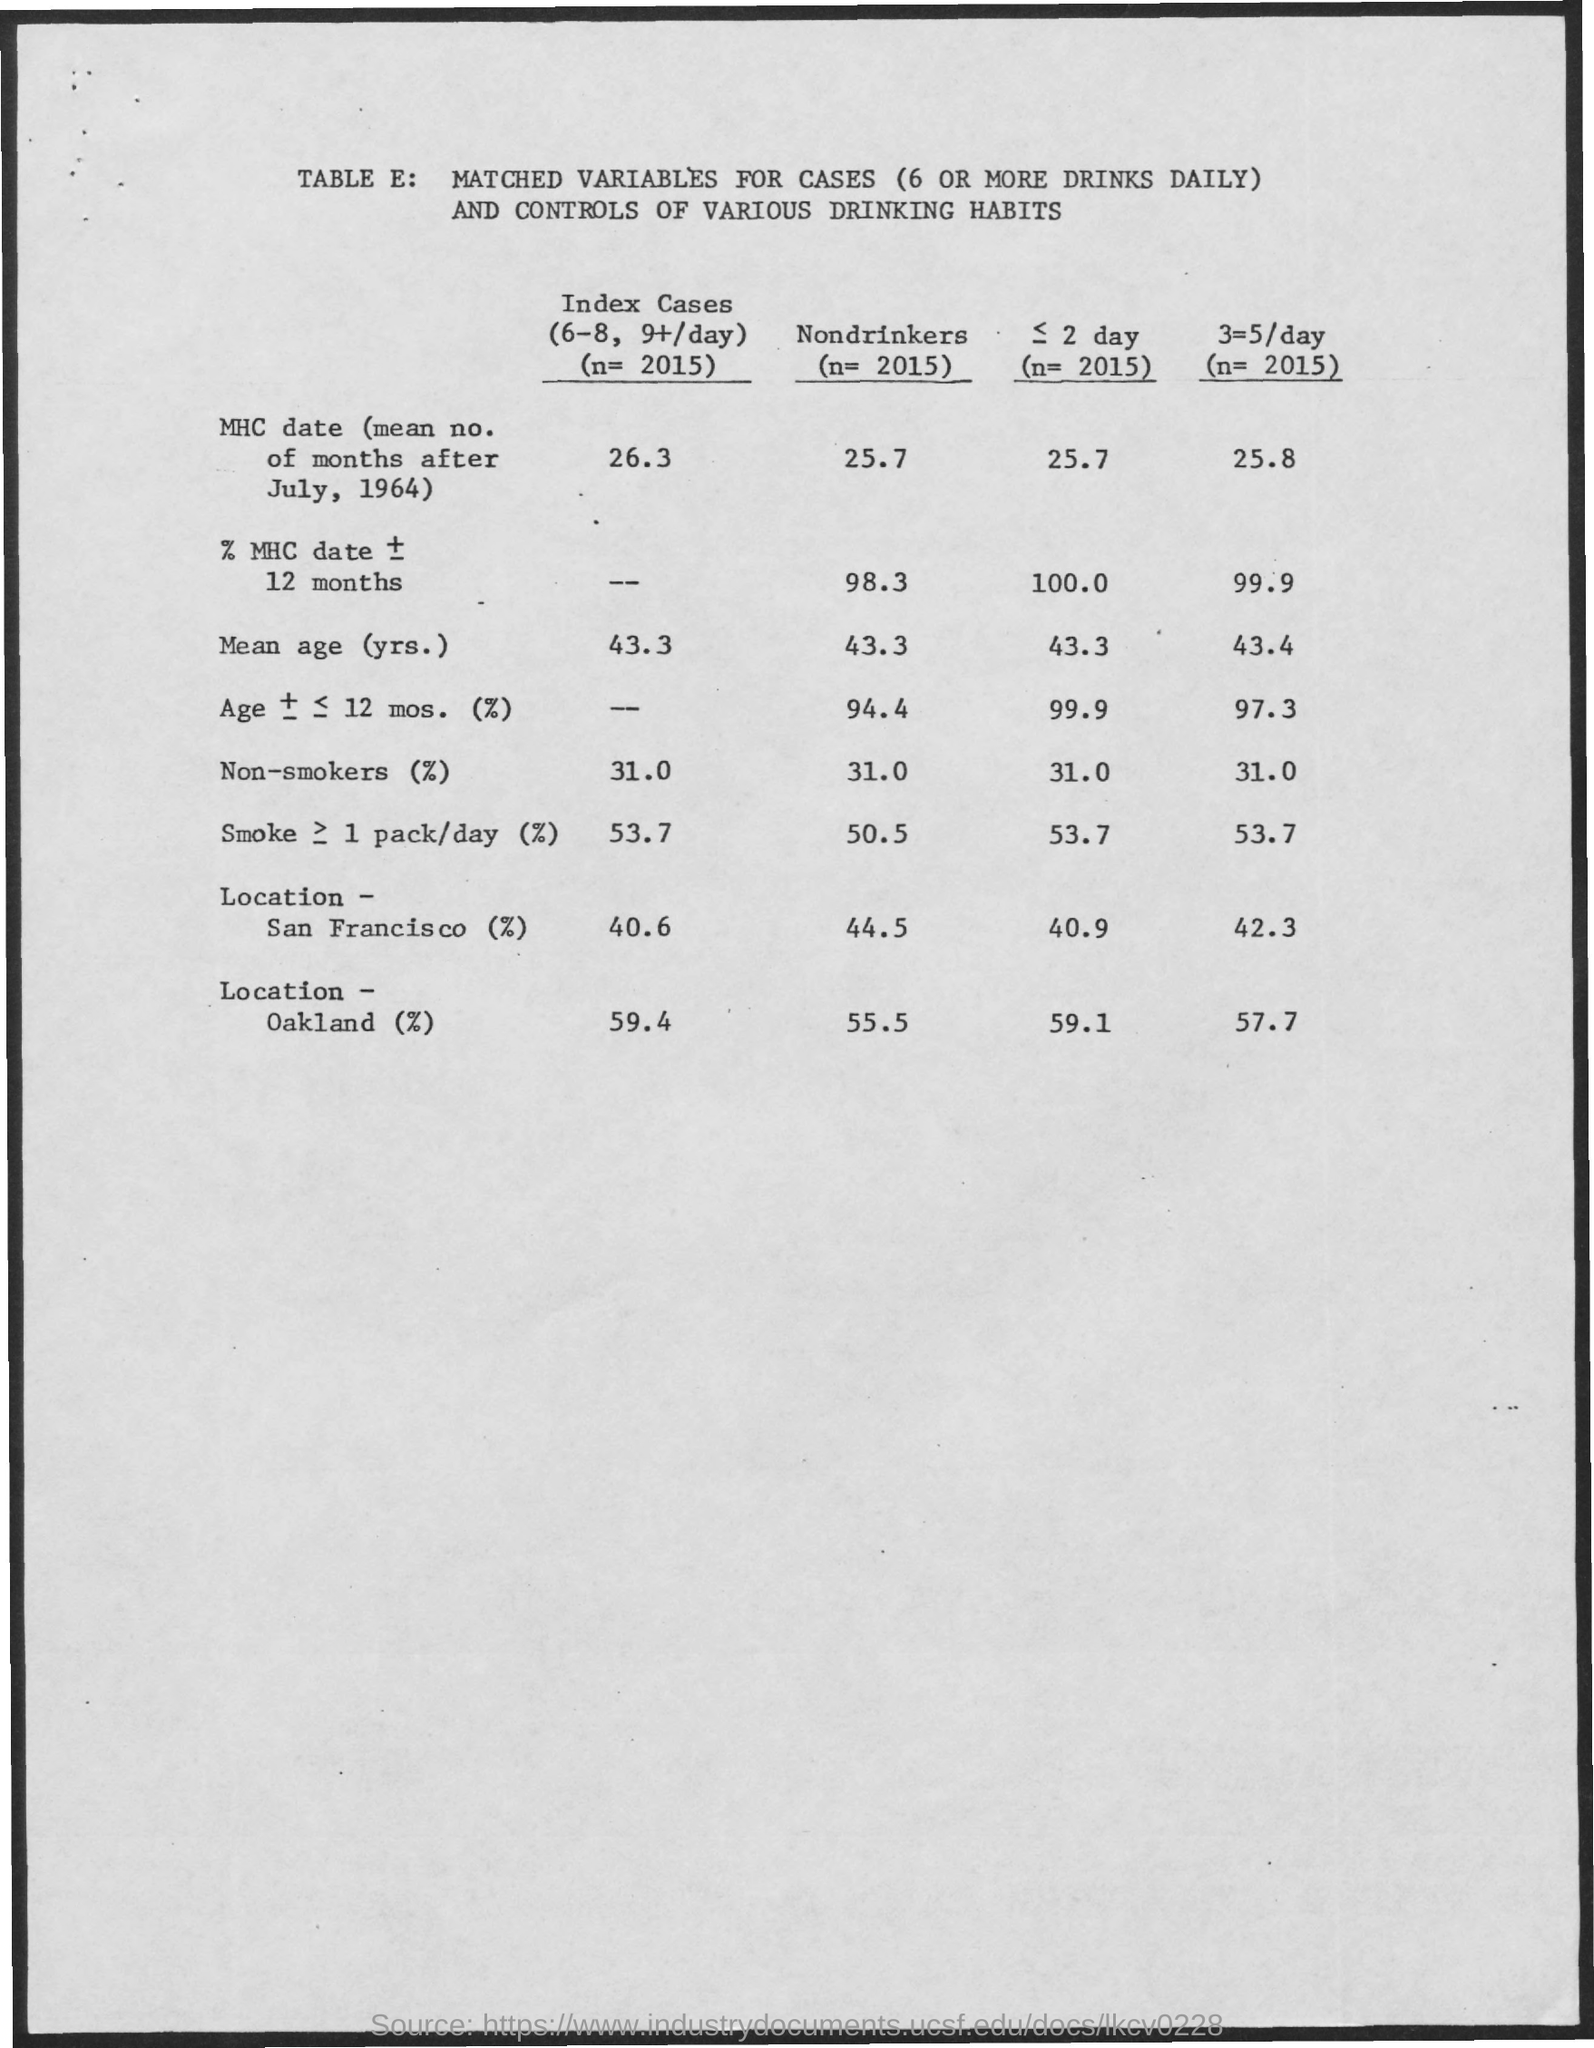Point out several critical features in this image. The value of nondrinkers in 2015 was 2015, with a mean age of 43.3 years. The value of nondrinkers in MHC data is 25.7 for the mean number of months after July 1964. 